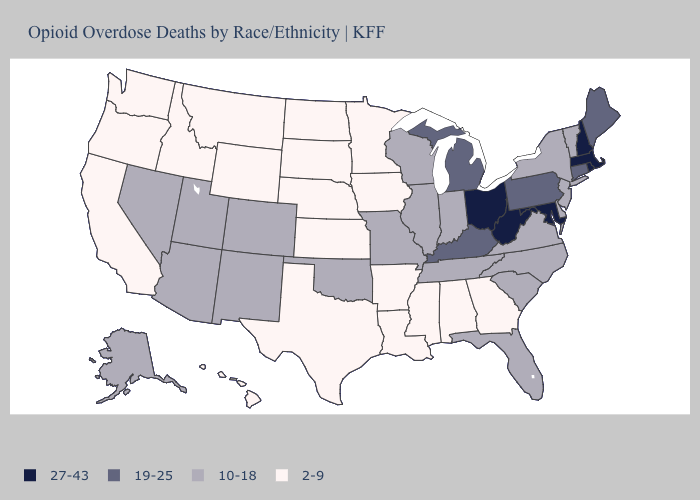Name the states that have a value in the range 10-18?
Quick response, please. Alaska, Arizona, Colorado, Delaware, Florida, Illinois, Indiana, Missouri, Nevada, New Jersey, New Mexico, New York, North Carolina, Oklahoma, South Carolina, Tennessee, Utah, Vermont, Virginia, Wisconsin. What is the highest value in the USA?
Write a very short answer. 27-43. Name the states that have a value in the range 2-9?
Keep it brief. Alabama, Arkansas, California, Georgia, Hawaii, Idaho, Iowa, Kansas, Louisiana, Minnesota, Mississippi, Montana, Nebraska, North Dakota, Oregon, South Dakota, Texas, Washington, Wyoming. Which states have the lowest value in the USA?
Answer briefly. Alabama, Arkansas, California, Georgia, Hawaii, Idaho, Iowa, Kansas, Louisiana, Minnesota, Mississippi, Montana, Nebraska, North Dakota, Oregon, South Dakota, Texas, Washington, Wyoming. What is the value of New York?
Short answer required. 10-18. Name the states that have a value in the range 19-25?
Answer briefly. Connecticut, Kentucky, Maine, Michigan, Pennsylvania. Does Oklahoma have the lowest value in the USA?
Write a very short answer. No. Does North Dakota have a lower value than Hawaii?
Be succinct. No. Name the states that have a value in the range 19-25?
Give a very brief answer. Connecticut, Kentucky, Maine, Michigan, Pennsylvania. Name the states that have a value in the range 10-18?
Be succinct. Alaska, Arizona, Colorado, Delaware, Florida, Illinois, Indiana, Missouri, Nevada, New Jersey, New Mexico, New York, North Carolina, Oklahoma, South Carolina, Tennessee, Utah, Vermont, Virginia, Wisconsin. Name the states that have a value in the range 19-25?
Short answer required. Connecticut, Kentucky, Maine, Michigan, Pennsylvania. What is the value of Hawaii?
Quick response, please. 2-9. Name the states that have a value in the range 2-9?
Be succinct. Alabama, Arkansas, California, Georgia, Hawaii, Idaho, Iowa, Kansas, Louisiana, Minnesota, Mississippi, Montana, Nebraska, North Dakota, Oregon, South Dakota, Texas, Washington, Wyoming. Name the states that have a value in the range 10-18?
Short answer required. Alaska, Arizona, Colorado, Delaware, Florida, Illinois, Indiana, Missouri, Nevada, New Jersey, New Mexico, New York, North Carolina, Oklahoma, South Carolina, Tennessee, Utah, Vermont, Virginia, Wisconsin. 